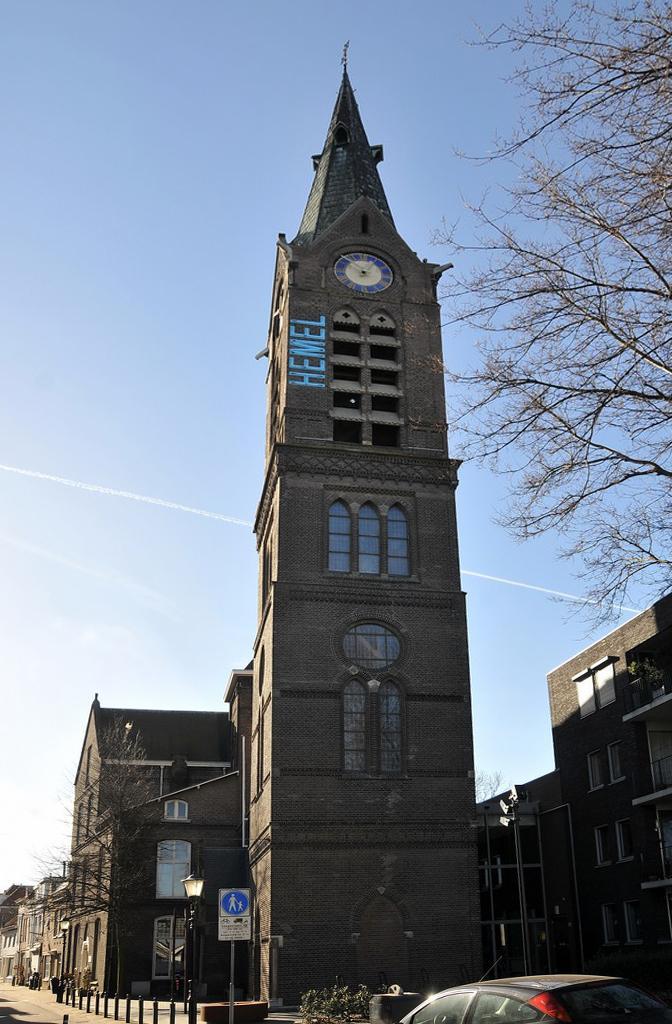How would you summarize this image in a sentence or two? In this picture we can see a clock tower and buildings. On the left side of the buildings, there are trees, street lights, lane poles and there is a pole with a signboard attached to it. Behind the clock tower, where is the sky. At the bottom of the image, there is a vehicle. 